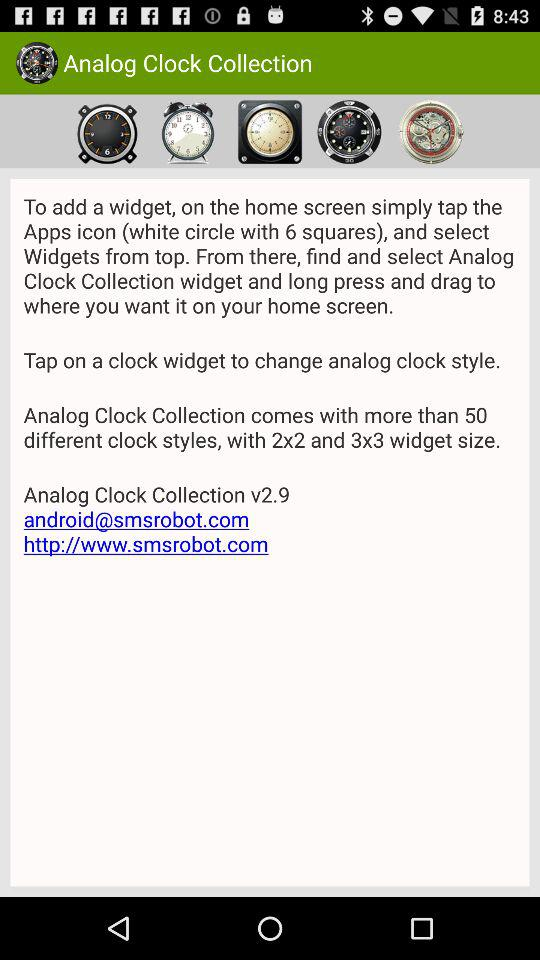What is the size of the clock widget? The sizes of the clock widget are 2x2 and 3x3. 